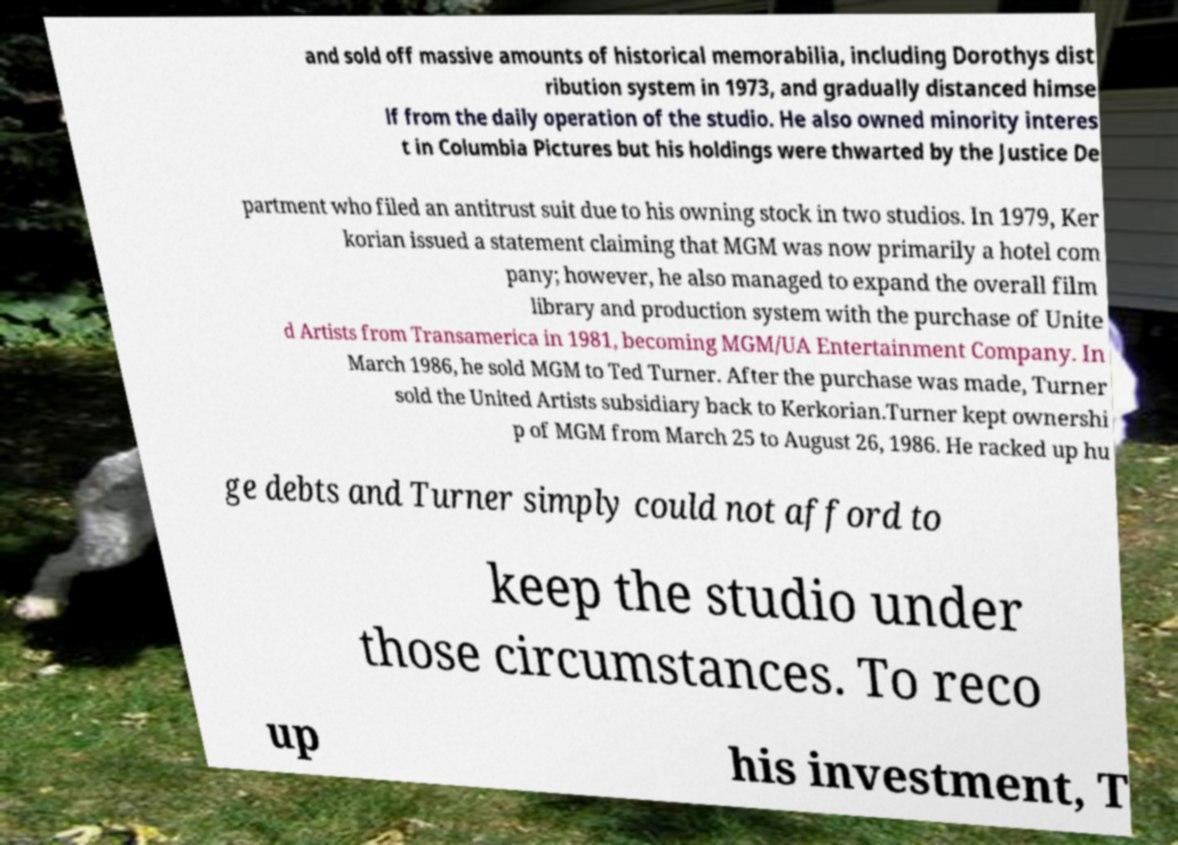I need the written content from this picture converted into text. Can you do that? and sold off massive amounts of historical memorabilia, including Dorothys dist ribution system in 1973, and gradually distanced himse lf from the daily operation of the studio. He also owned minority interes t in Columbia Pictures but his holdings were thwarted by the Justice De partment who filed an antitrust suit due to his owning stock in two studios. In 1979, Ker korian issued a statement claiming that MGM was now primarily a hotel com pany; however, he also managed to expand the overall film library and production system with the purchase of Unite d Artists from Transamerica in 1981, becoming MGM/UA Entertainment Company. In March 1986, he sold MGM to Ted Turner. After the purchase was made, Turner sold the United Artists subsidiary back to Kerkorian.Turner kept ownershi p of MGM from March 25 to August 26, 1986. He racked up hu ge debts and Turner simply could not afford to keep the studio under those circumstances. To reco up his investment, T 